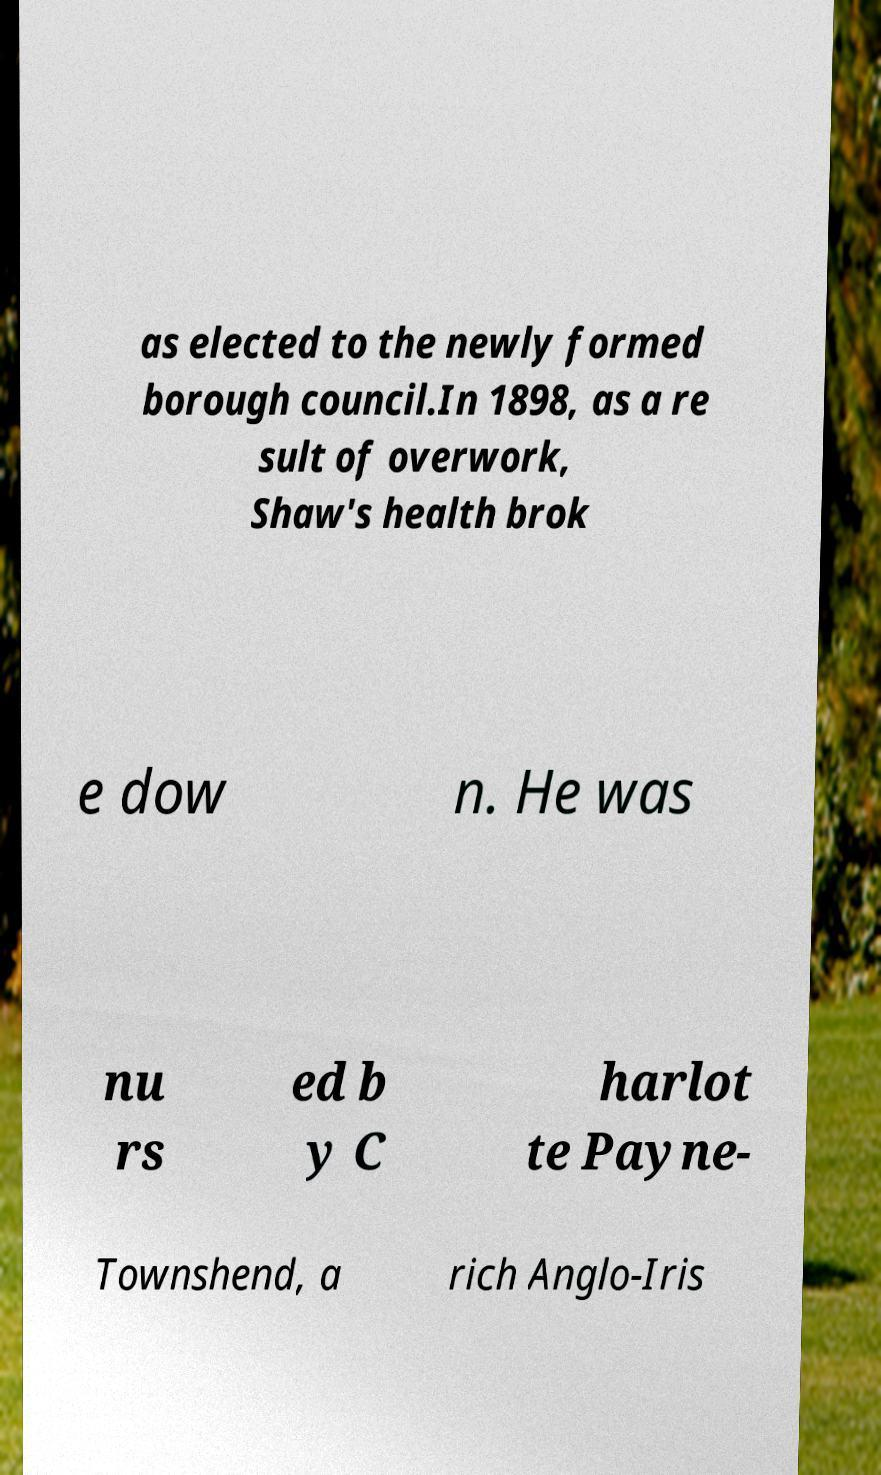What messages or text are displayed in this image? I need them in a readable, typed format. as elected to the newly formed borough council.In 1898, as a re sult of overwork, Shaw's health brok e dow n. He was nu rs ed b y C harlot te Payne- Townshend, a rich Anglo-Iris 